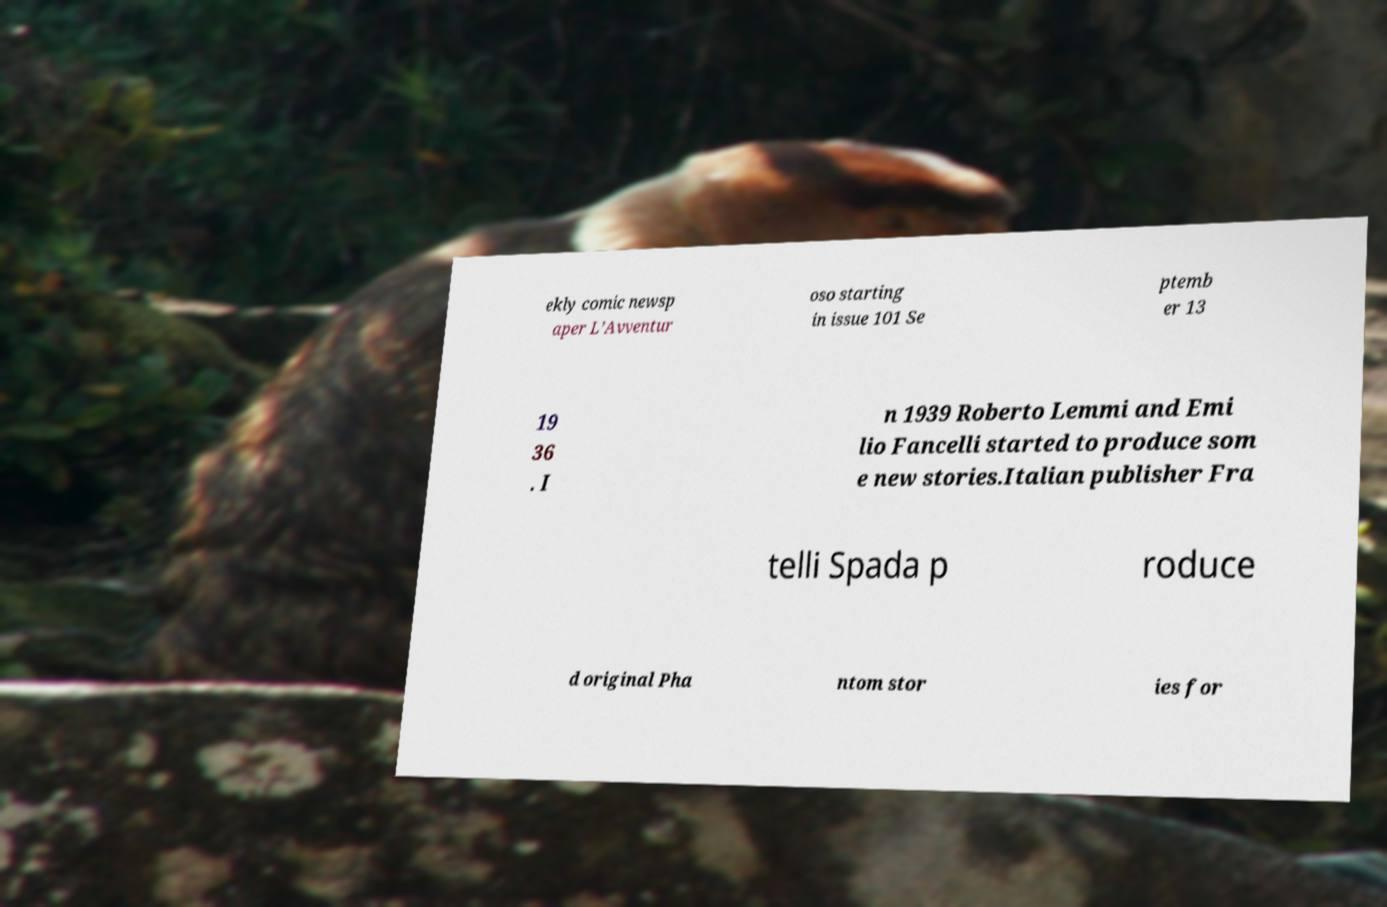For documentation purposes, I need the text within this image transcribed. Could you provide that? ekly comic newsp aper L’Avventur oso starting in issue 101 Se ptemb er 13 19 36 . I n 1939 Roberto Lemmi and Emi lio Fancelli started to produce som e new stories.Italian publisher Fra telli Spada p roduce d original Pha ntom stor ies for 